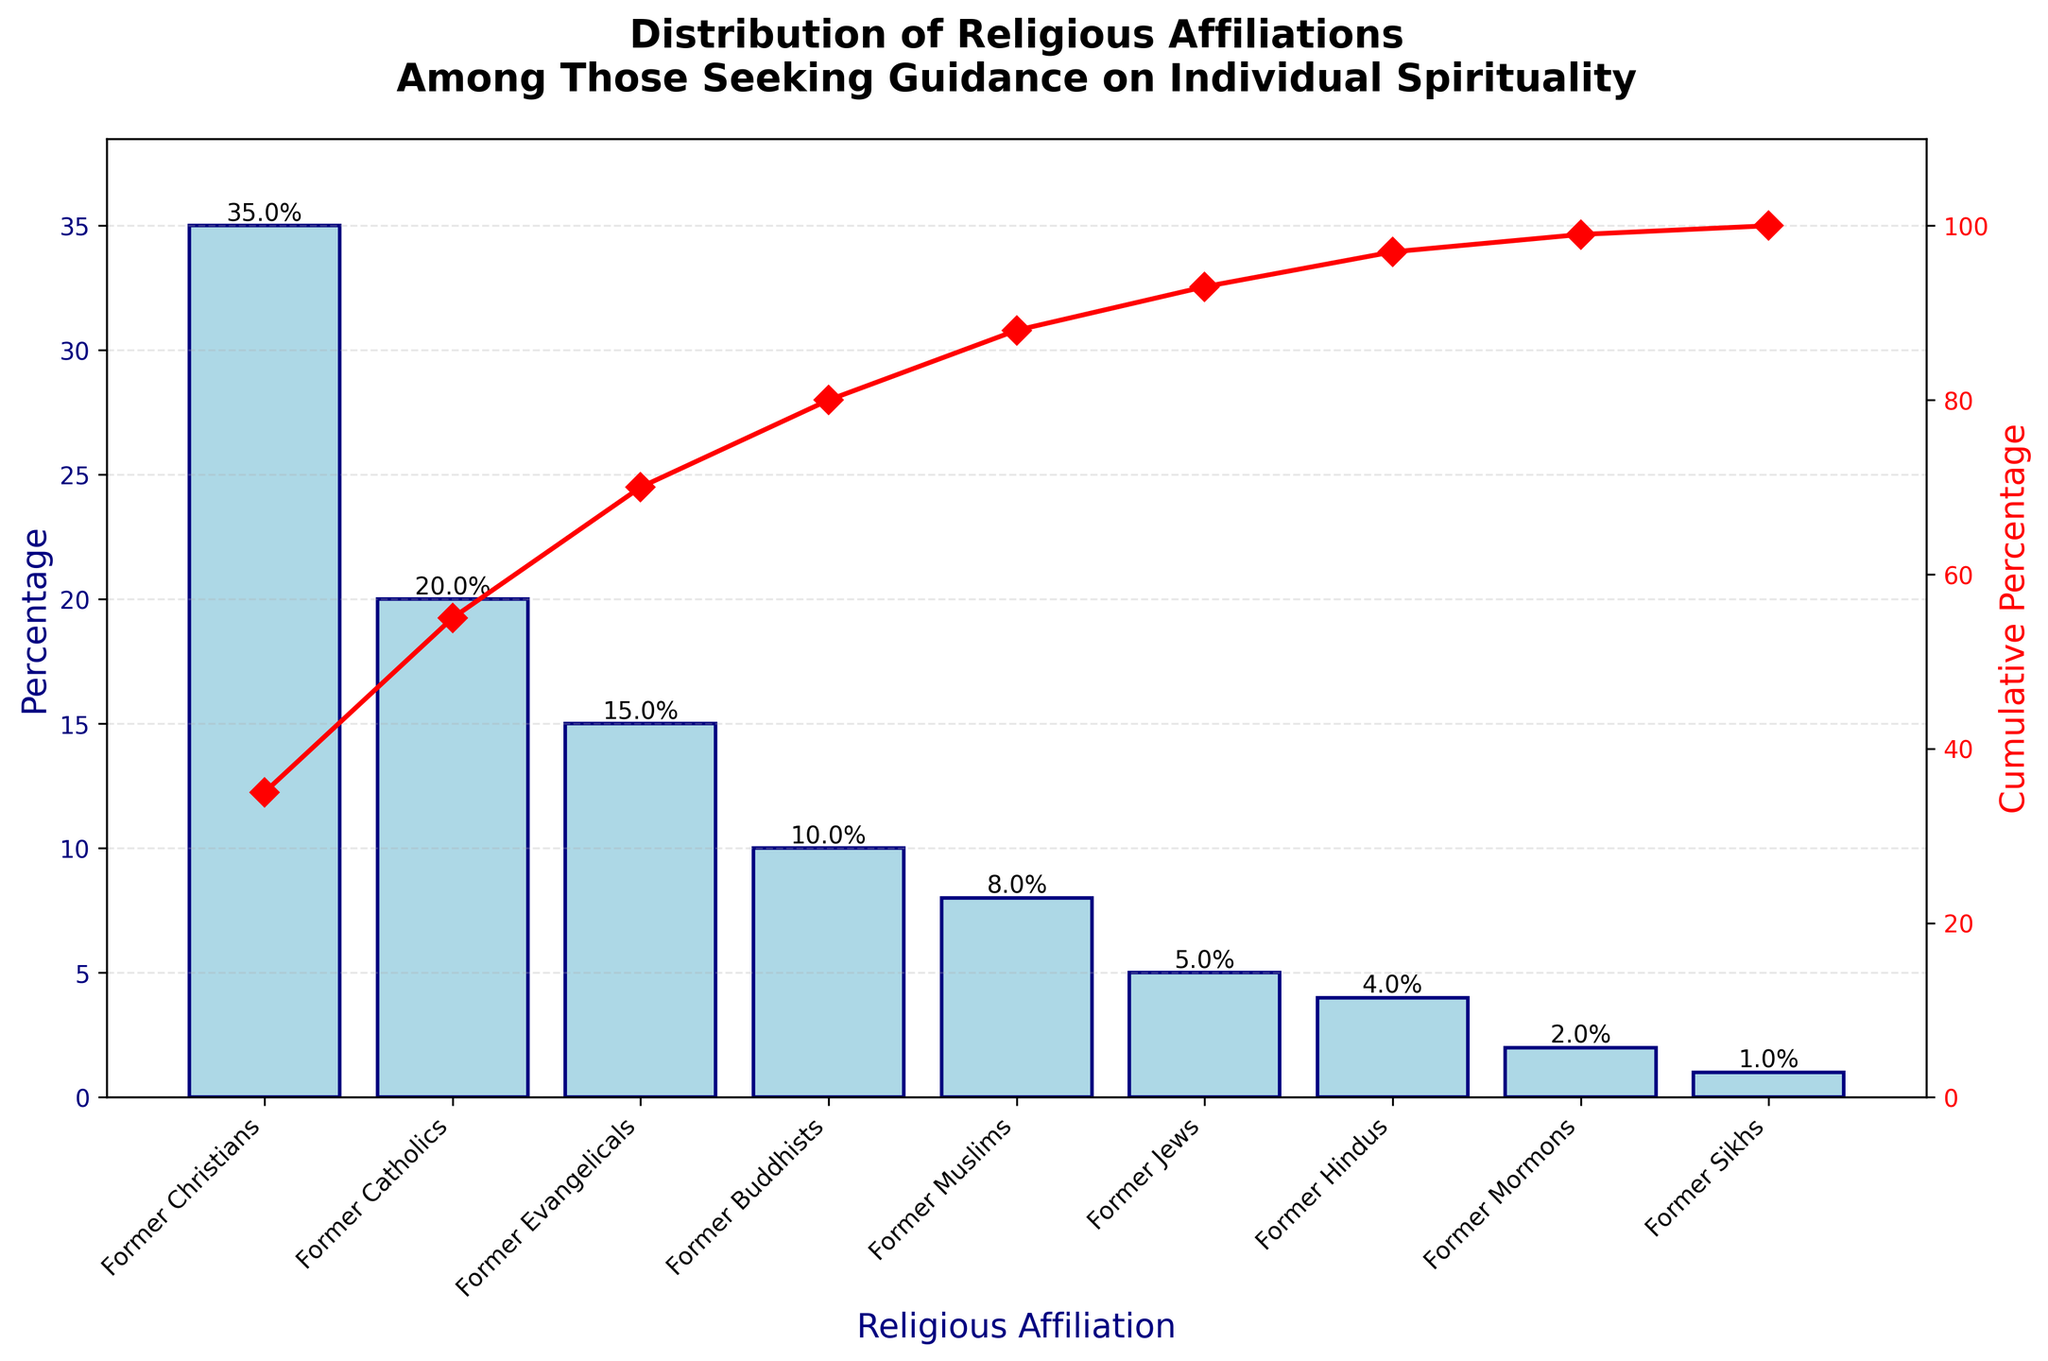What is the title of the figure? The title is displayed prominently at the top of the figure in large, bold text.
Answer: Distribution of Religious Affiliations Among Those Seeking Guidance on Individual Spirituality What are the axes labels? The labels are found along the vertical and horizontal axes. The left y-axis is labeled "Percentage," and the right y-axis is labeled "Cumulative Percentage." The x-axis is labeled "Religious Affiliation."
Answer: Percentage, Cumulative Percentage, Religious Affiliation Which religious affiliation has the highest percentage? The religious affiliation with the tallest bar in the bar chart represents the highest percentage. "Former Christians" has the tallest bar.
Answer: Former Christians What is the cumulative percentage for "Former Buddhists"? The cumulative percentage line for "Former Buddhists" is where you can see its plot point on the line chart. Follow the line from "Former Buddhists" on the x-axis to the red plot line and read the value on the right y-axis, which looks slightly above 80%.
Answer: 80% How many religious affiliations are represented in the figure? Count the number of distinct bars in the bar chart, each representing a different religious affiliation.
Answer: 9 What is the percentage difference between "Former Catholics" and "Former Evangelicals"? Subtract the percentage of "Former Evangelicals" from the percentage of "Former Catholics." The percentages are 20% for "Former Catholics" and 15% for "Former Evangelicals." 20% - 15% = 5%.
Answer: 5% What is the cumulative percentage for "Former Mormons" and below? Find the cumulative percentage for "Former Mormons" and identify the values for all smaller affiliations. Add these together. The values are 35% + 20% + 15% + 10% + 8% + 5% + 4% + 2%.
Answer: 99% Which two affiliations have the smallest percentages, and what are they? Identify the two smallest bars in the bar chart. These affiliations are "Former Sikhs" and "Former Mormons." Their percentages are 1% and 2%, respectively.
Answer: Former Sikhs, Former Mormons What percentage of people seeking guidance were "Former Jews," "Former Hindus," and "Former Mormons"? Add the percentages of these three affiliations. The values are 5% (Former Jews) + 4% (Former Hindus) + 2% (Former Mormons). 5% + 4% + 2% = 11%.
Answer: 11% What percentage range do the middle three categories ("Former Evangelicals", "Former Buddhists", and "Former Muslims") fall within? Add the percentages of the three middle categories. The values are 15% (Former Evangelicals) + 10% (Former Buddhists) + 8% (Former Muslims). 15% + 10% + 8% = 33%.
Answer: 33% 